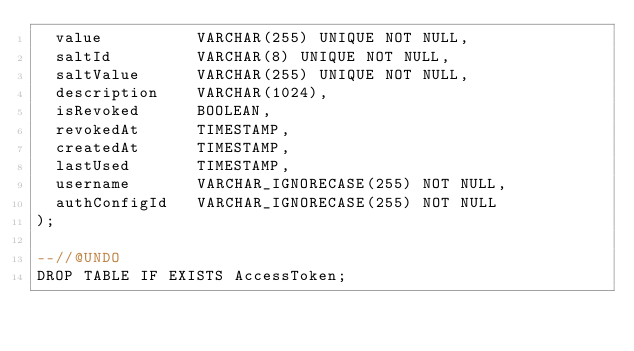Convert code to text. <code><loc_0><loc_0><loc_500><loc_500><_SQL_>  value          VARCHAR(255) UNIQUE NOT NULL,
  saltId         VARCHAR(8) UNIQUE NOT NULL,
  saltValue      VARCHAR(255) UNIQUE NOT NULL,
  description    VARCHAR(1024),
  isRevoked      BOOLEAN,
  revokedAt      TIMESTAMP,
  createdAt      TIMESTAMP,
  lastUsed       TIMESTAMP,
  username       VARCHAR_IGNORECASE(255) NOT NULL,
  authConfigId   VARCHAR_IGNORECASE(255) NOT NULL
);

--//@UNDO
DROP TABLE IF EXISTS AccessToken;
</code> 